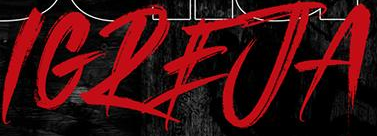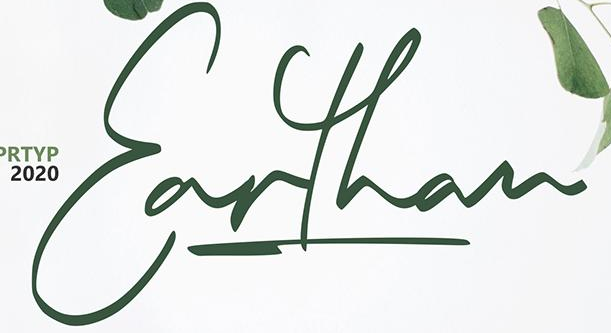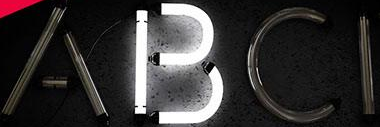Identify the words shown in these images in order, separated by a semicolon. IGREJA; Earthan; ABCI 